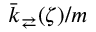<formula> <loc_0><loc_0><loc_500><loc_500>\bar { k } _ { \right l e f t a r r o w s } ( \zeta ) / m</formula> 